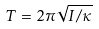Convert formula to latex. <formula><loc_0><loc_0><loc_500><loc_500>T = 2 \pi \sqrt { I / \kappa }</formula> 